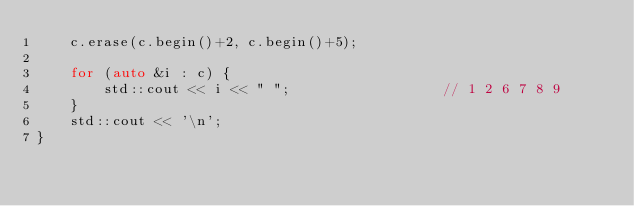Convert code to text. <code><loc_0><loc_0><loc_500><loc_500><_C++_>    c.erase(c.begin()+2, c.begin()+5);

    for (auto &i : c) {
        std::cout << i << " ";                  // 1 2 6 7 8 9
    }
    std::cout << '\n';
}
</code> 